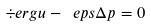Convert formula to latex. <formula><loc_0><loc_0><loc_500><loc_500>\div e r g u - \ e p s \Delta p = 0</formula> 